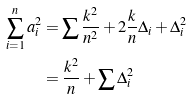<formula> <loc_0><loc_0><loc_500><loc_500>\sum _ { i = 1 } ^ { n } a _ { i } ^ { 2 } & = \sum \frac { k ^ { 2 } } { n ^ { 2 } } + 2 \frac { k } { n } \Delta _ { i } + \Delta _ { i } ^ { 2 } \\ & = \frac { k ^ { 2 } } { n } + \sum \Delta _ { i } ^ { 2 }</formula> 